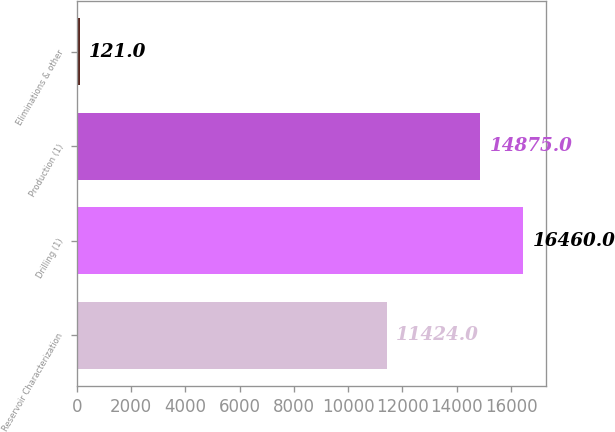Convert chart. <chart><loc_0><loc_0><loc_500><loc_500><bar_chart><fcel>Reservoir Characterization<fcel>Drilling (1)<fcel>Production (1)<fcel>Eliminations & other<nl><fcel>11424<fcel>16460<fcel>14875<fcel>121<nl></chart> 